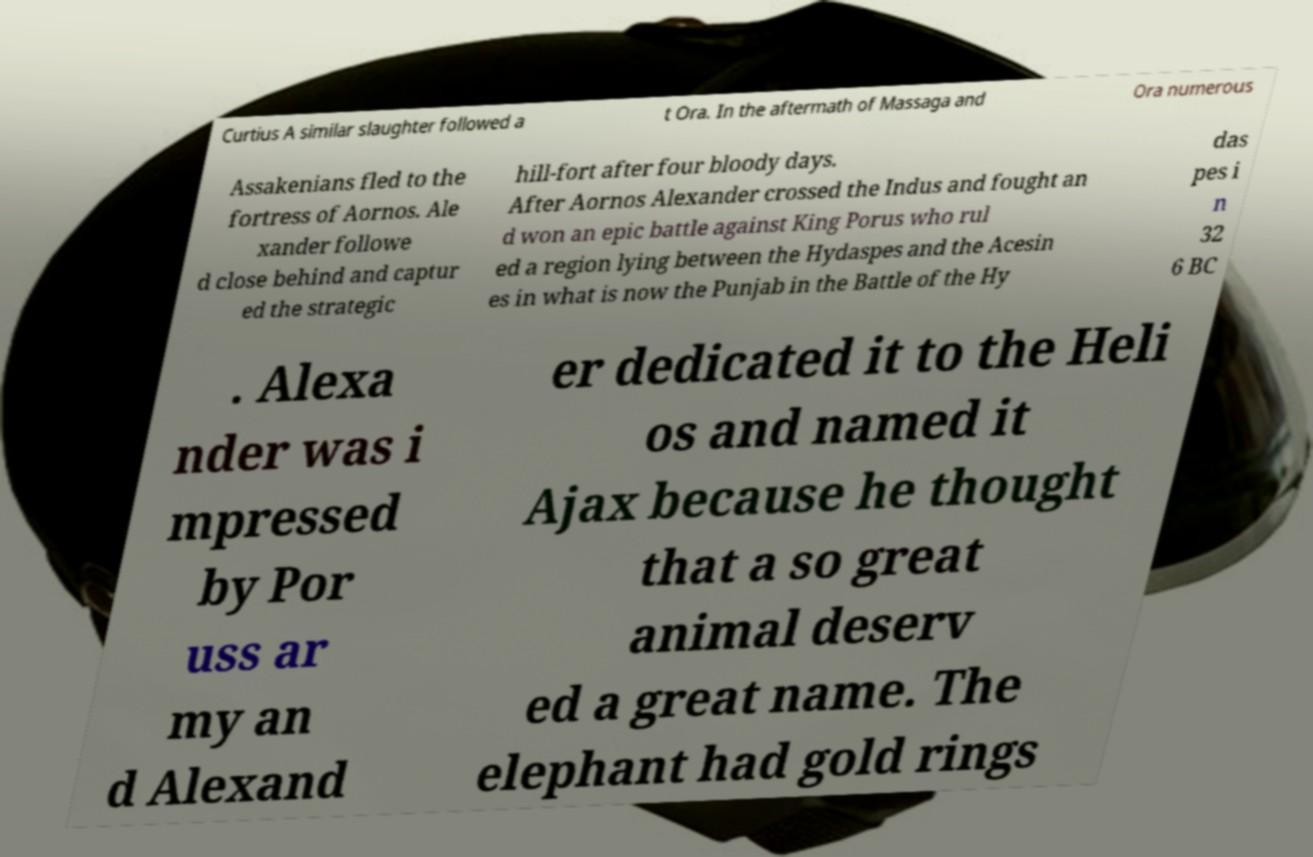Could you assist in decoding the text presented in this image and type it out clearly? Curtius A similar slaughter followed a t Ora. In the aftermath of Massaga and Ora numerous Assakenians fled to the fortress of Aornos. Ale xander followe d close behind and captur ed the strategic hill-fort after four bloody days. After Aornos Alexander crossed the Indus and fought an d won an epic battle against King Porus who rul ed a region lying between the Hydaspes and the Acesin es in what is now the Punjab in the Battle of the Hy das pes i n 32 6 BC . Alexa nder was i mpressed by Por uss ar my an d Alexand er dedicated it to the Heli os and named it Ajax because he thought that a so great animal deserv ed a great name. The elephant had gold rings 